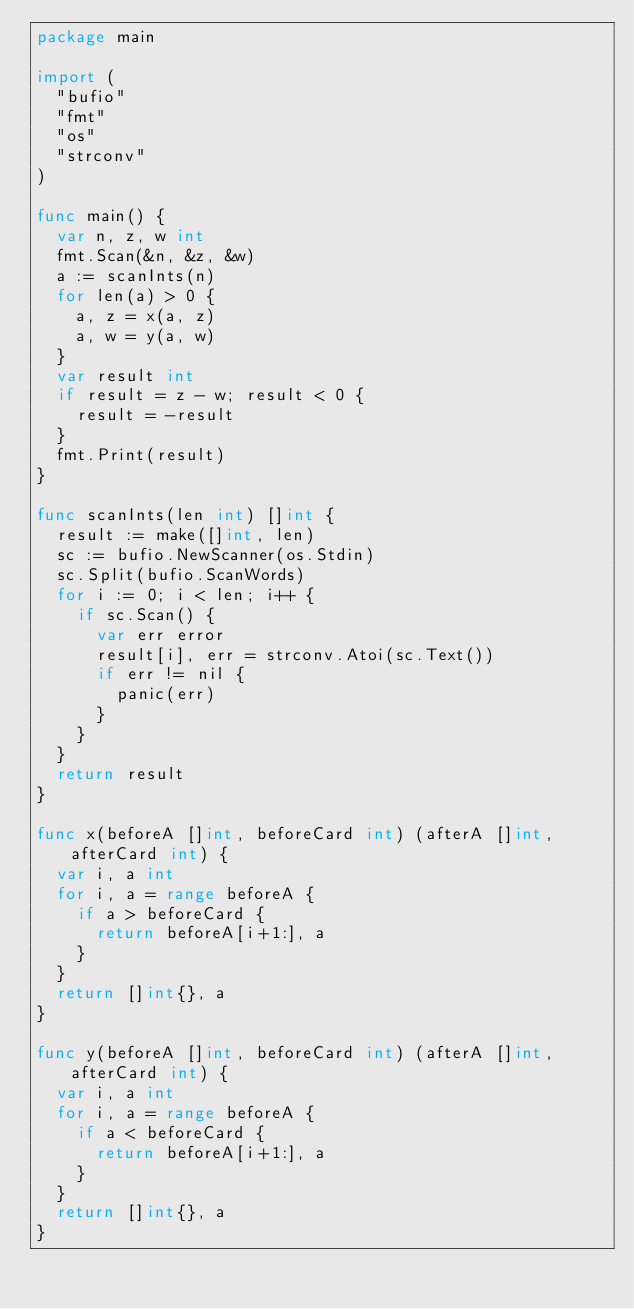<code> <loc_0><loc_0><loc_500><loc_500><_Go_>package main

import (
	"bufio"
	"fmt"
	"os"
	"strconv"
)

func main() {
	var n, z, w int
	fmt.Scan(&n, &z, &w)
	a := scanInts(n)
	for len(a) > 0 {
		a, z = x(a, z)
		a, w = y(a, w)
	}
	var result int
	if result = z - w; result < 0 {
		result = -result
	}
	fmt.Print(result)
}

func scanInts(len int) []int {
	result := make([]int, len)
	sc := bufio.NewScanner(os.Stdin)
	sc.Split(bufio.ScanWords)
	for i := 0; i < len; i++ {
		if sc.Scan() {
			var err error
			result[i], err = strconv.Atoi(sc.Text())
			if err != nil {
				panic(err)
			}
		}
	}
	return result
}

func x(beforeA []int, beforeCard int) (afterA []int, afterCard int) {
	var i, a int
	for i, a = range beforeA {
		if a > beforeCard {
			return beforeA[i+1:], a
		}
	}
	return []int{}, a
}

func y(beforeA []int, beforeCard int) (afterA []int, afterCard int) {
	var i, a int
	for i, a = range beforeA {
		if a < beforeCard {
			return beforeA[i+1:], a
		}
	}
	return []int{}, a
}
</code> 